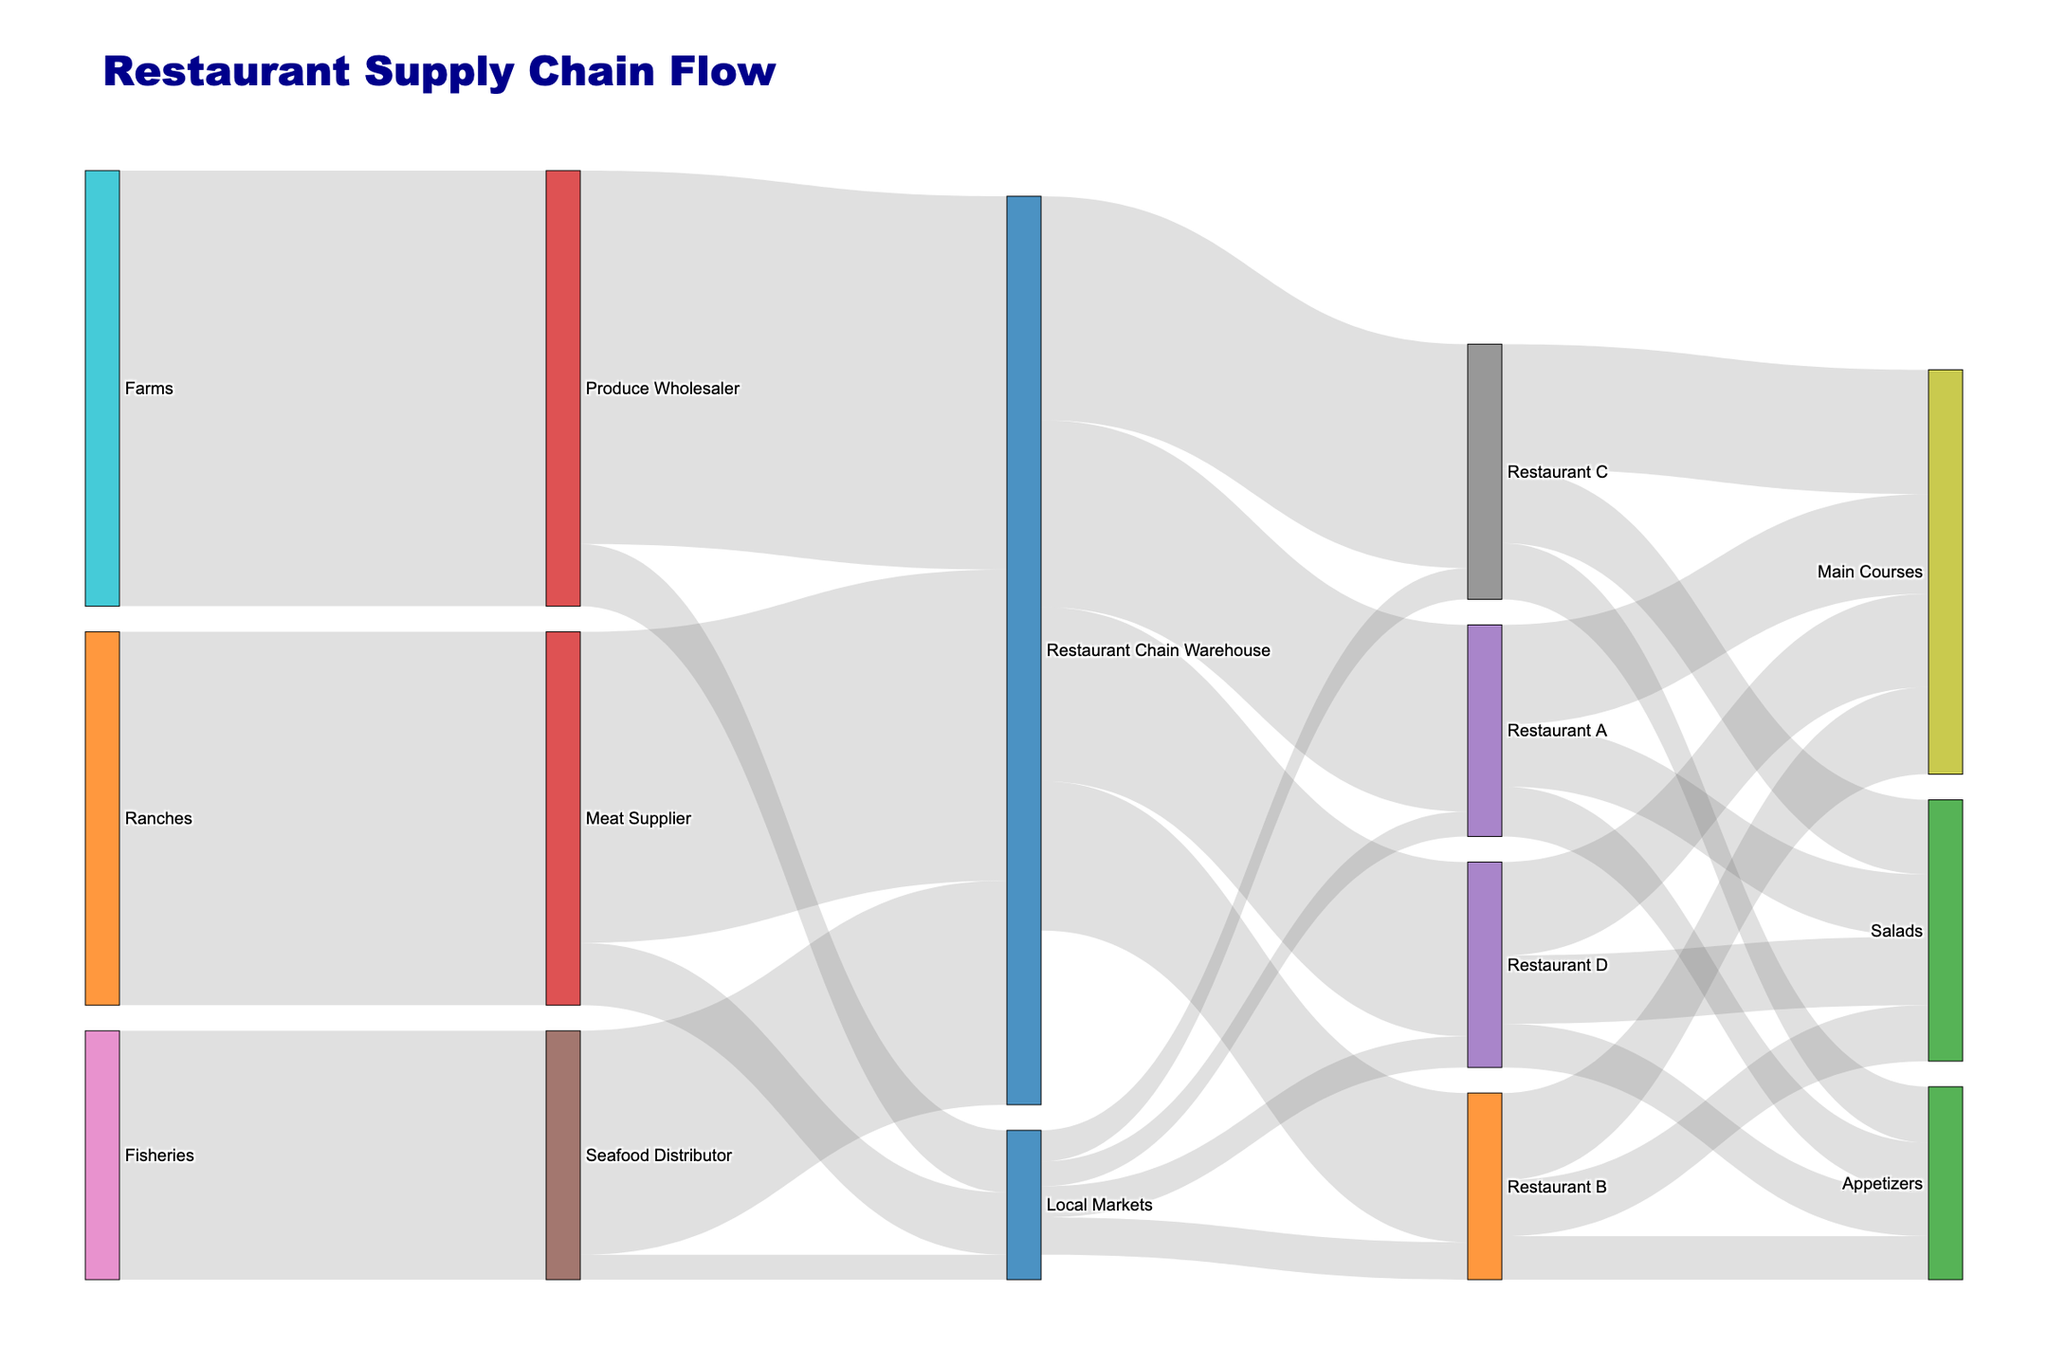What is the main title of the diagram? The main title of a diagram is usually easy to spot at the top and provides an overall idea of what the diagram is about. In this case, the title is prominent due to its font size and style.
Answer: Restaurant Supply Chain Flow From which sources does the Restaurant Chain Warehouse receive its supplies? By following the links leading to the Restaurant Chain Warehouse, you can identify all the sources. These links include Produce Wholesaler, Seafood Distributor, and Meat Supplier.
Answer: Produce Wholesaler, Seafood Distributor, Meat Supplier How many units of produce come from the Farms to the Produce Wholesaler? You can identify this by tracing the link from Farms to Produce Wholesaler and noting the value associated with it. According to the data provided, the value is 350.
Answer: 350 Which restaurant receives the most supplies from the Restaurant Chain Warehouse and how much? To find this, look at the links coming out from Restaurant Chain Warehouse and compare their values. Restaurant C receives the most with 180 units.
Answer: Restaurant C, 180 What is the total amount of supplies received by Local Markets from all sources combined? To answer this, sum the values from all links leading to Local Markets: 50 (from Produce Wholesaler) + 20 (from Seafood Distributor) + 50 (from Meat Supplier) = 120.
Answer: 120 Which dish category at Restaurant A uses the most supplies? By examining the links originating from Restaurant A and the values associated with each category, Main Courses use the most with 80 units.
Answer: Main Courses What is the combined value of supplies received by Restaurants B and D from Local Markets? This involves adding the values of supplies to Restaurant B and Restaurant D from Local Markets: 30 (B) + 25 (D) = 55.
Answer: 55 Compare the amount of seafood received by the Restaurant Chain Warehouse and Local Markets. Which one receives more? By comparing the values from Seafood Distributor to both destinations, Restaurant Chain Warehouse receives 180 units, while Local Markets receive 20 units. Hence, the Restaurant Chain Warehouse receives more.
Answer: Restaurant Chain Warehouse How many units of supplies go from Restaurant Chain Warehouse to all restaurants combined? Add the values of supplies going from Restaurant Chain Warehouse to each restaurant: 150 (A) + 120 (B) + 180 (C) + 140 (D) = 590.
Answer: 590 What is the total supply used by Restaurant C for all dishes? Add the values for each dish category in Restaurant C: 60 (Salads) + 100 (Main Courses) + 45 (Appetizers) = 205.
Answer: 205 